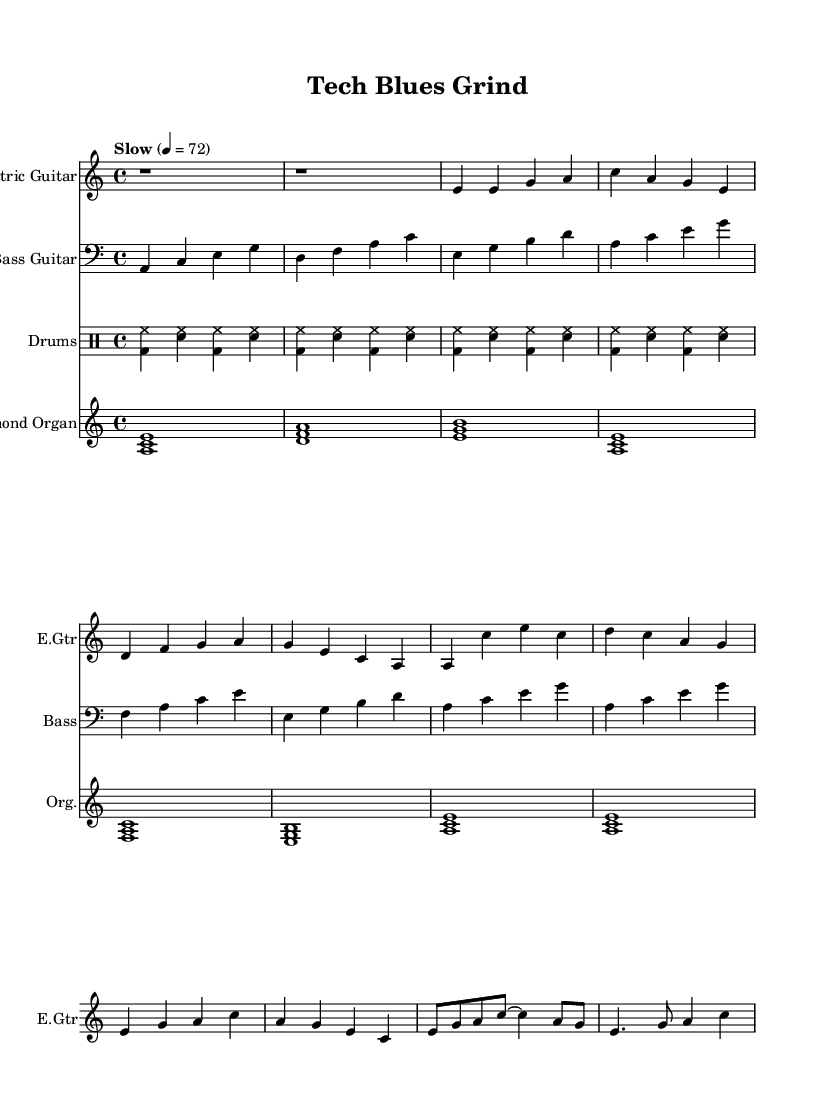What is the key signature of this music? The key signature is indicated by the key signature symbol at the beginning of the staff. In this case, it shows "A minor," which has no sharps or flats.
Answer: A minor What is the time signature of this music? The time signature appears at the beginning of the staff and indicates how many beats are in a measure; here, it is "4/4," meaning four beats per measure.
Answer: 4/4 What is the tempo marking indicated in the sheet music? The tempo is specified at the beginning of the score with a phrase that indicates speed. It mentions "Slow" at a quarter note equals 72 beats per minute, which is a specified tempo.
Answer: Slow How many measures are in the chorus section? To determine this, we need to examine the portion labeled as the chorus in the music. Counting the measures from the written music sequence, there are four measures in the chorus section.
Answer: 4 What is the main instrument for the melody in this piece? The primary melody is typically identified by the main staff that plays the most prominent notes. Here, the "Electric Guitar" part carries the primary melody.
Answer: Electric Guitar What is the chord progression played by the Hammond Organ? By analyzing the notes written for the Hammond Organ, we can identify the chord sequence which in this case is a series of simple triads. Listing them from left to right gives us the progression: A minor, D minor, E minor, A minor… etc.
Answer: A minor, D minor, E minor What genre does this piece reflect through its structure and instrumentation? The genre can be discerned from the style and instrumentation, including characteristics typical of the type. Given the electric guitar, a slow tempo, and bluesy rhythms, it is clear that this is a representation of Electric Blues.
Answer: Electric Blues 